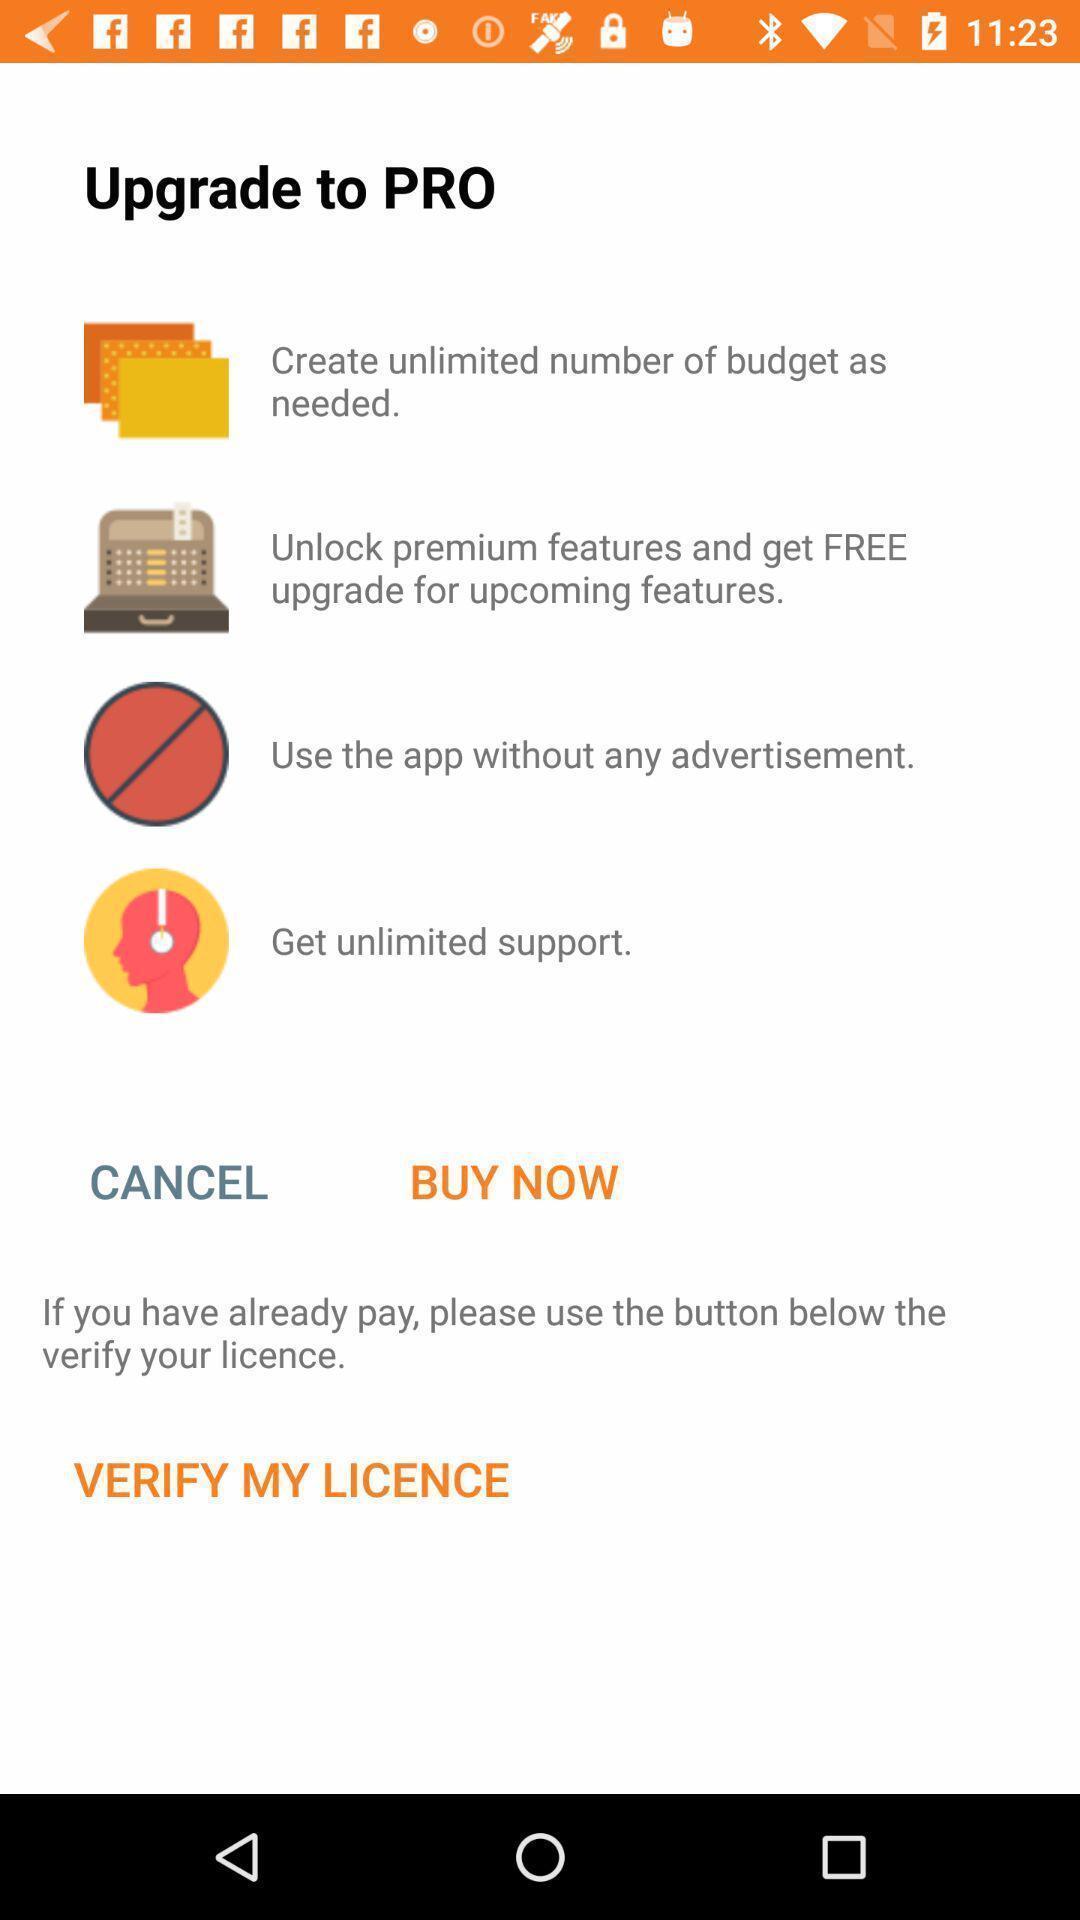Provide a description of this screenshot. Page showing upgrade to pro. 